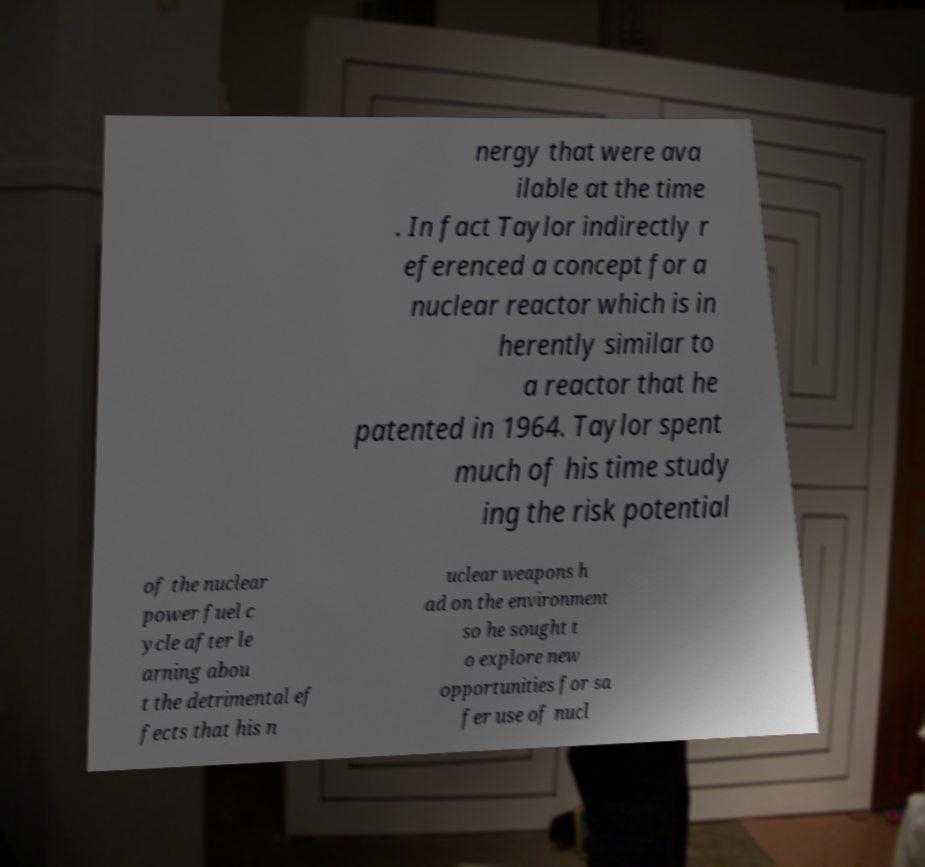For documentation purposes, I need the text within this image transcribed. Could you provide that? nergy that were ava ilable at the time . In fact Taylor indirectly r eferenced a concept for a nuclear reactor which is in herently similar to a reactor that he patented in 1964. Taylor spent much of his time study ing the risk potential of the nuclear power fuel c ycle after le arning abou t the detrimental ef fects that his n uclear weapons h ad on the environment so he sought t o explore new opportunities for sa fer use of nucl 